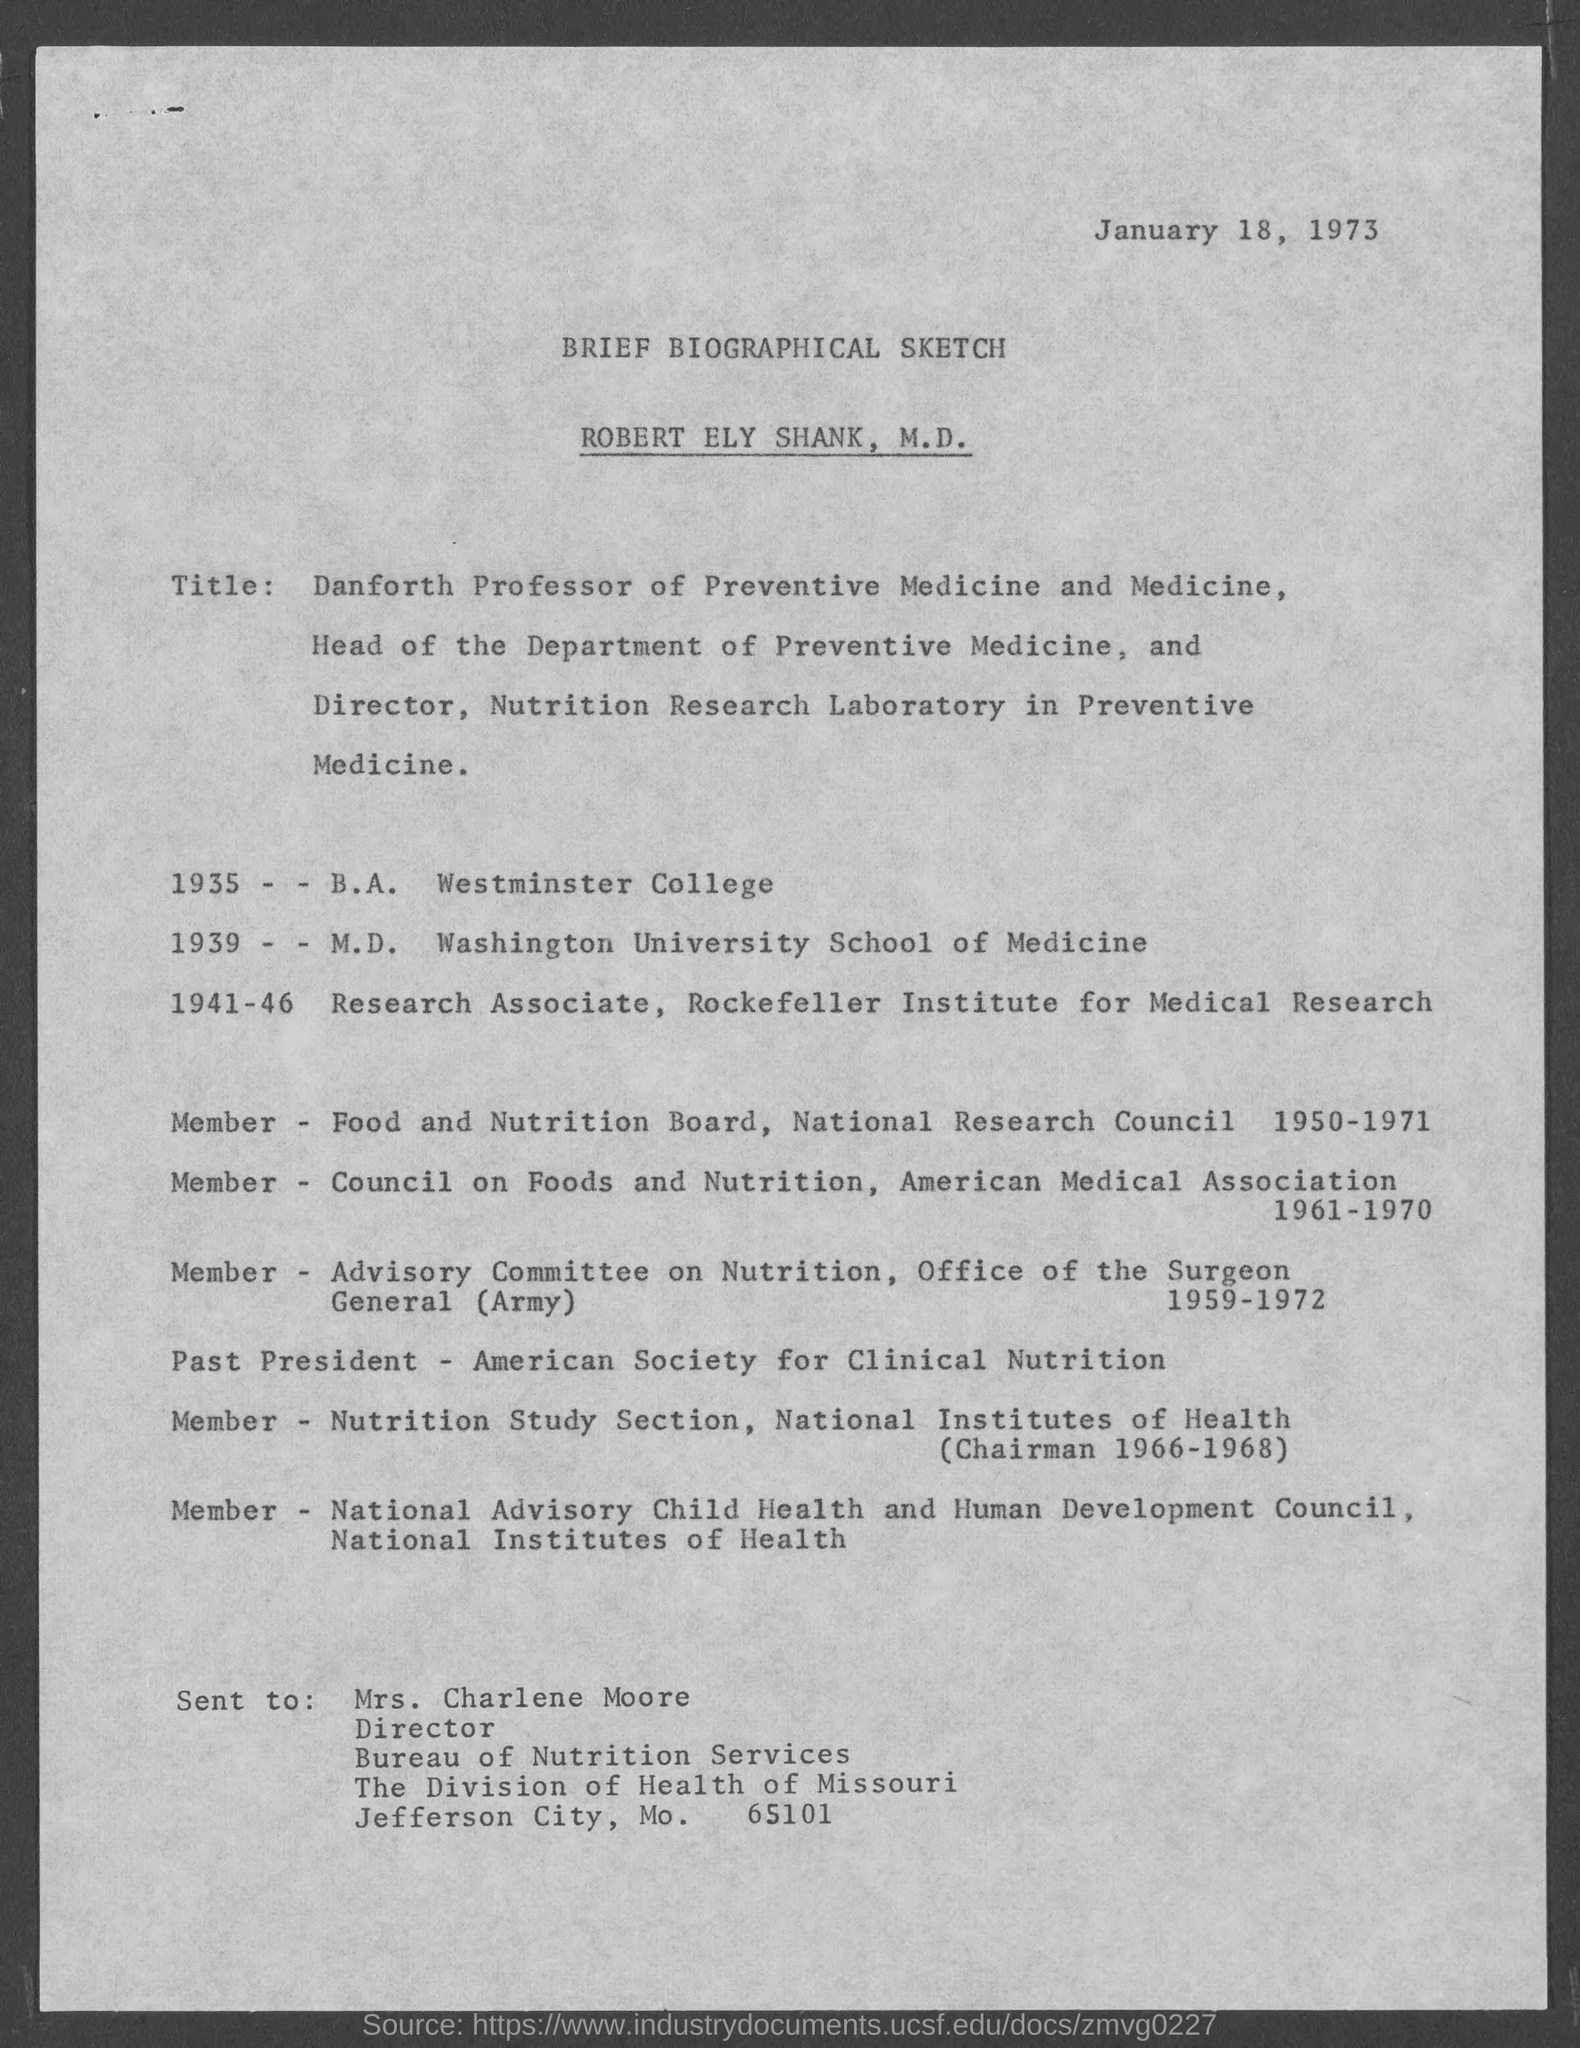Mention a couple of crucial points in this snapshot. The letter was sent to Mrs. Charlene Moore. The date mentioned in the given page is January 18, 1973. Mrs. Charlene Moore is the Director. The given page contains a sketch that is unknown, and a brief biographical sketch of a person is provided. 